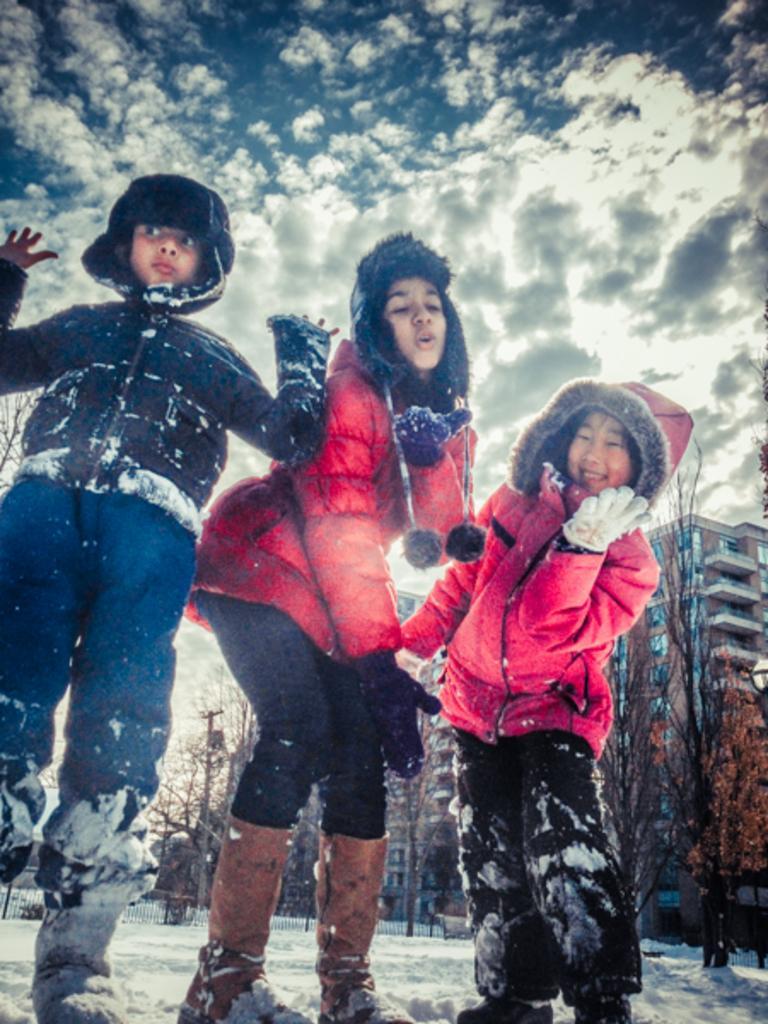Please provide a concise description of this image. As we can see in the image in the front there are three people standing. There is snow, trees, buildings, current pole, sky and clouds. 